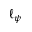<formula> <loc_0><loc_0><loc_500><loc_500>\ell _ { \psi }</formula> 